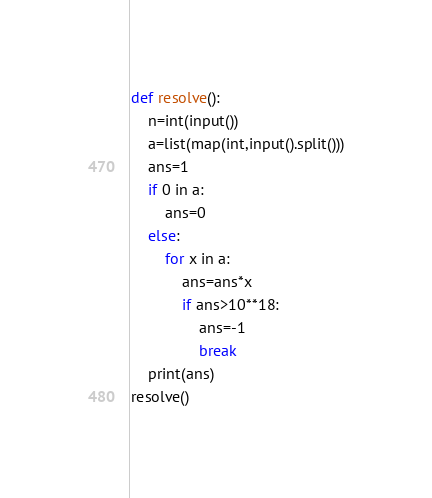Convert code to text. <code><loc_0><loc_0><loc_500><loc_500><_Python_>def resolve():
    n=int(input())
    a=list(map(int,input().split()))
    ans=1
    if 0 in a:
        ans=0
    else:
        for x in a:
            ans=ans*x
            if ans>10**18:
                ans=-1
                break
    print(ans)
resolve()
</code> 